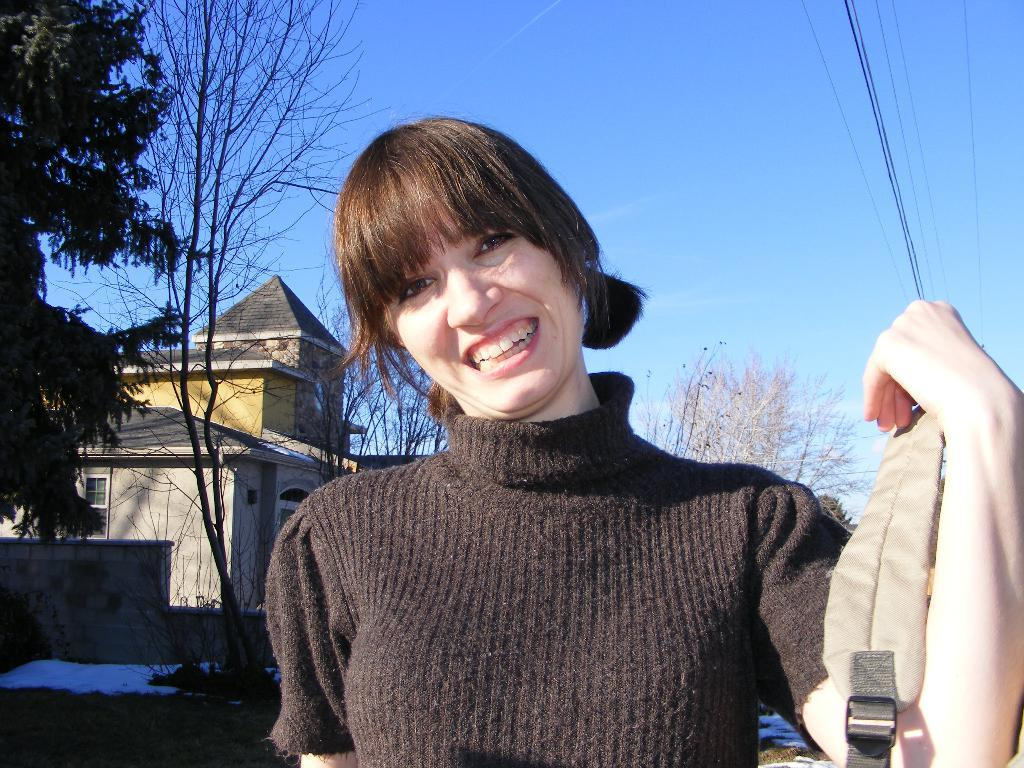What is the main subject in the foreground of the picture? There is a woman in the foreground of the picture. What is the woman wearing? The woman is wearing a back dress. What is the woman holding in her hand? The woman is holding a bag in her hand. What can be seen in the background of the picture? There are trees, a house, cables, and the sky visible in the background of the picture. What type of light can be seen coming from the stem in the image? There is no stem or light present in the image. 